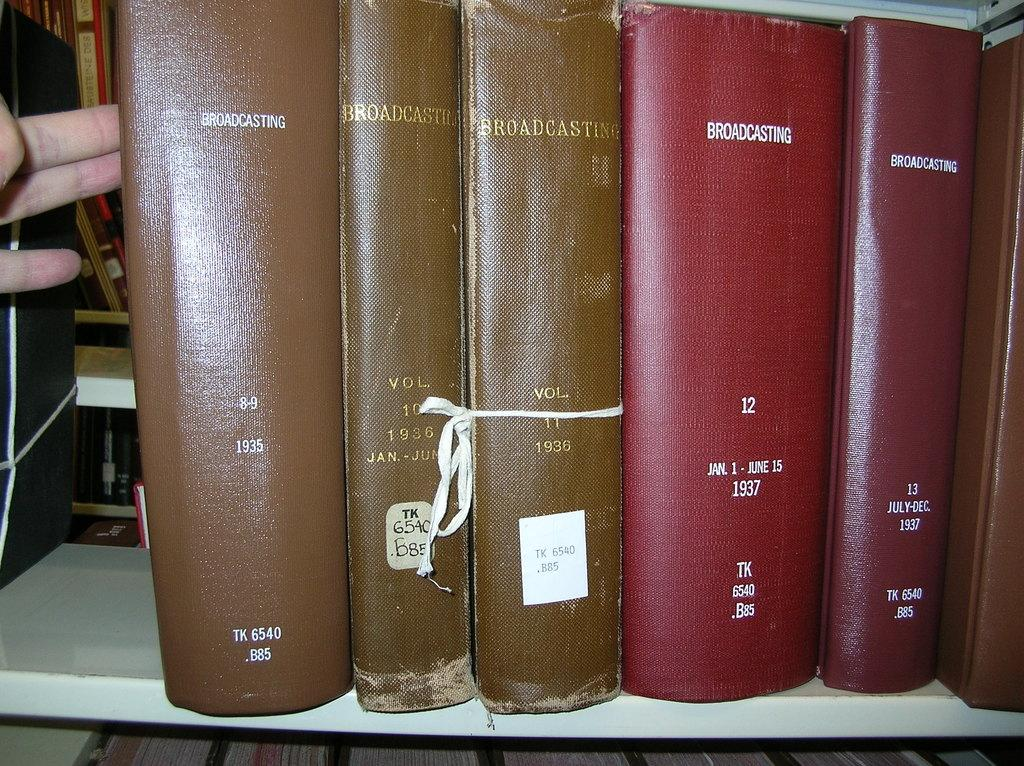<image>
Describe the image concisely. An old brown book titled Broadcasting was published in 1935 